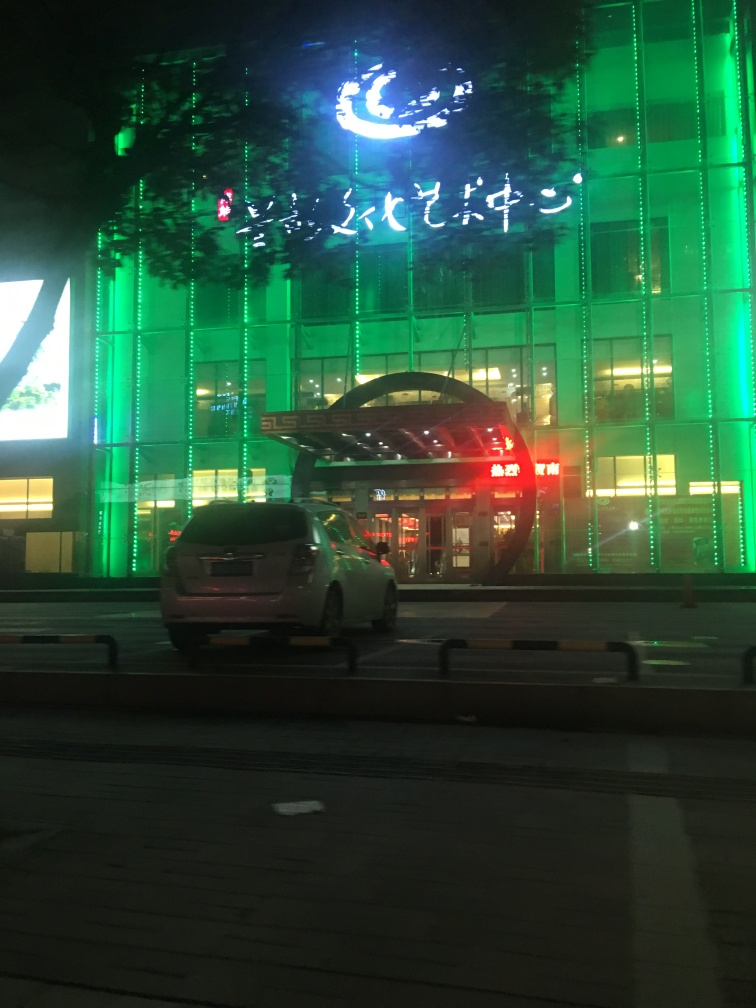What time of day does this image appear to have been taken? Based on the illuminated streetlights and building lights, as well as the dark sky, it appears the image was taken during the night time. What kind of mood does the lighting in this image evoke? The green lighting on the building and the vibrant neon sign evoke a lively and dynamic mood, often associated with urban nightlife or commercial areas that come alive after dark. 